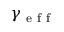Convert formula to latex. <formula><loc_0><loc_0><loc_500><loc_500>\gamma _ { e f f }</formula> 